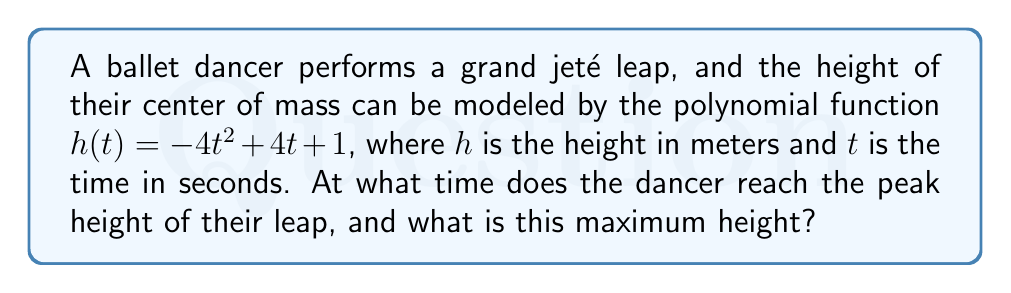Could you help me with this problem? To find the peak of the grand jeté leap, we need to determine the maximum point of the quadratic function $h(t) = -4t^2 + 4t + 1$. This can be done in the following steps:

1) The general form of a quadratic function is $f(x) = ax^2 + bx + c$, where $a$, $b$, and $c$ are constants and $a \neq 0$. In our case, $a = -4$, $b = 4$, and $c = 1$.

2) For a quadratic function, the x-coordinate of the vertex (which represents the time at maximum height in this case) is given by the formula:

   $t = -\frac{b}{2a}$

3) Substituting our values:

   $t = -\frac{4}{2(-4)} = -\frac{4}{-8} = \frac{1}{2} = 0.5$ seconds

4) To find the maximum height, we substitute this t-value back into our original function:

   $h(0.5) = -4(0.5)^2 + 4(0.5) + 1$
   
   $= -4(0.25) + 2 + 1$
   
   $= -1 + 2 + 1 = 2$ meters

Therefore, the dancer reaches the peak of their leap at 0.5 seconds, and the maximum height achieved is 2 meters.
Answer: Time at peak: 0.5 seconds; Maximum height: 2 meters 